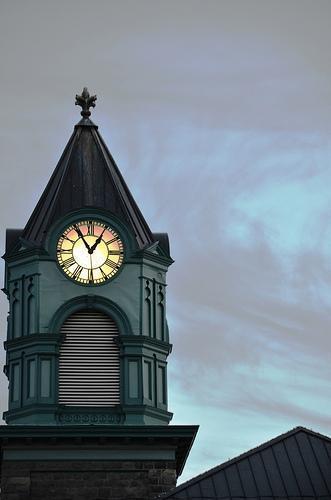How many clocks?
Give a very brief answer. 1. How many buildings?
Give a very brief answer. 1. 